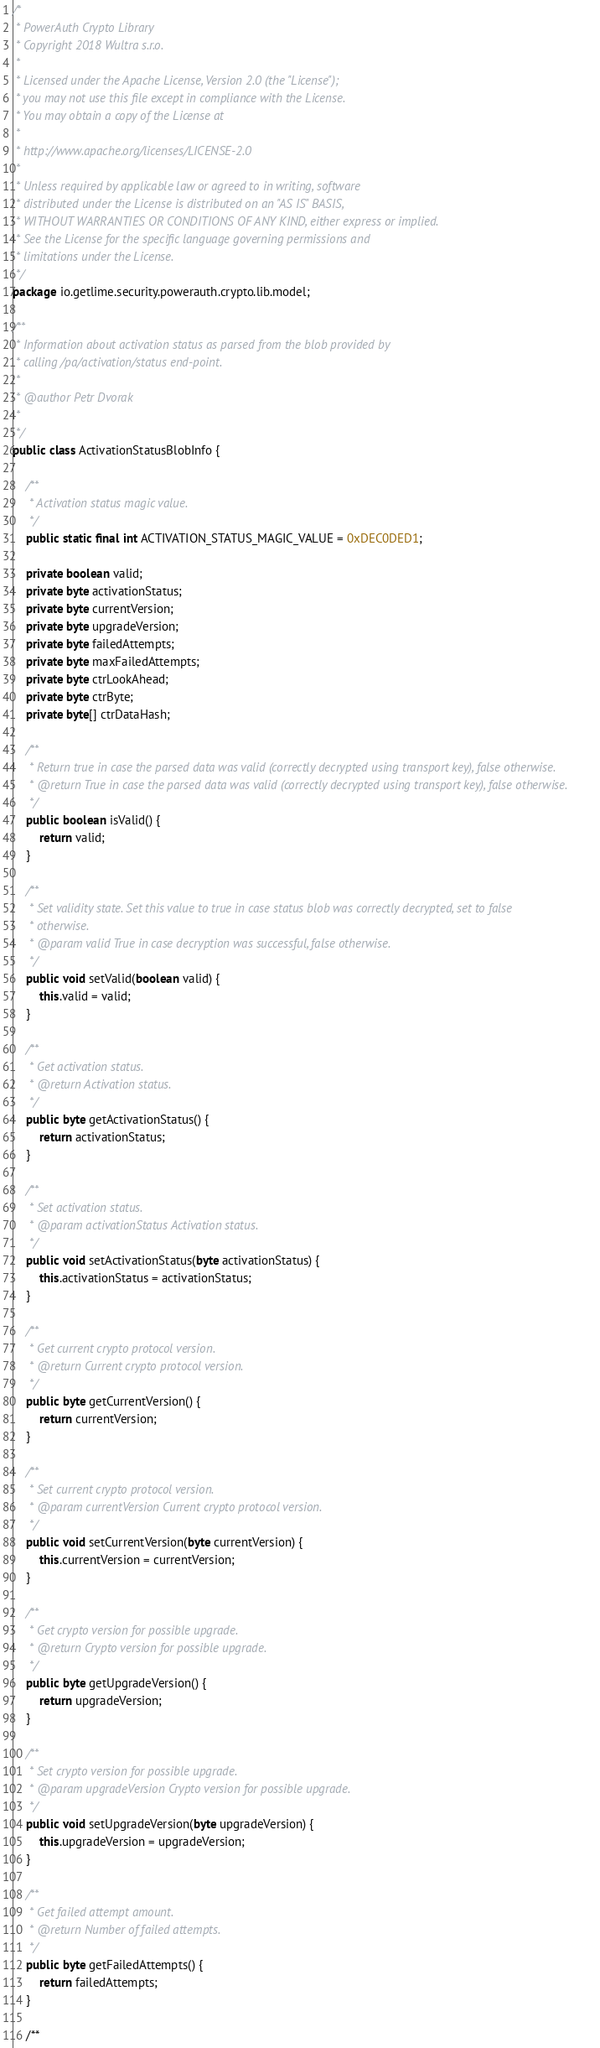<code> <loc_0><loc_0><loc_500><loc_500><_Java_>/*
 * PowerAuth Crypto Library
 * Copyright 2018 Wultra s.r.o.
 *
 * Licensed under the Apache License, Version 2.0 (the "License");
 * you may not use this file except in compliance with the License.
 * You may obtain a copy of the License at
 *
 * http://www.apache.org/licenses/LICENSE-2.0
 *
 * Unless required by applicable law or agreed to in writing, software
 * distributed under the License is distributed on an "AS IS" BASIS,
 * WITHOUT WARRANTIES OR CONDITIONS OF ANY KIND, either express or implied.
 * See the License for the specific language governing permissions and
 * limitations under the License.
 */
package io.getlime.security.powerauth.crypto.lib.model;

/**
 * Information about activation status as parsed from the blob provided by
 * calling /pa/activation/status end-point.
 *
 * @author Petr Dvorak
 *
 */
public class ActivationStatusBlobInfo {

    /**
     * Activation status magic value.
     */
    public static final int ACTIVATION_STATUS_MAGIC_VALUE = 0xDEC0DED1;

    private boolean valid;
    private byte activationStatus;
    private byte currentVersion;
    private byte upgradeVersion;
    private byte failedAttempts;
    private byte maxFailedAttempts;
    private byte ctrLookAhead;
    private byte ctrByte;
    private byte[] ctrDataHash;

    /**
     * Return true in case the parsed data was valid (correctly decrypted using transport key), false otherwise.
     * @return True in case the parsed data was valid (correctly decrypted using transport key), false otherwise.
     */
    public boolean isValid() {
        return valid;
    }

    /**
     * Set validity state. Set this value to true in case status blob was correctly decrypted, set to false
     * otherwise.
     * @param valid True in case decryption was successful, false otherwise.
     */
    public void setValid(boolean valid) {
        this.valid = valid;
    }

    /**
     * Get activation status.
     * @return Activation status.
     */
    public byte getActivationStatus() {
        return activationStatus;
    }

    /**
     * Set activation status.
     * @param activationStatus Activation status.
     */
    public void setActivationStatus(byte activationStatus) {
        this.activationStatus = activationStatus;
    }

    /**
     * Get current crypto protocol version.
     * @return Current crypto protocol version.
     */
    public byte getCurrentVersion() {
        return currentVersion;
    }

    /**
     * Set current crypto protocol version.
     * @param currentVersion Current crypto protocol version.
     */
    public void setCurrentVersion(byte currentVersion) {
        this.currentVersion = currentVersion;
    }

    /**
     * Get crypto version for possible upgrade.
     * @return Crypto version for possible upgrade.
     */
    public byte getUpgradeVersion() {
        return upgradeVersion;
    }

    /**
     * Set crypto version for possible upgrade.
     * @param upgradeVersion Crypto version for possible upgrade.
     */
    public void setUpgradeVersion(byte upgradeVersion) {
        this.upgradeVersion = upgradeVersion;
    }

    /**
     * Get failed attempt amount.
     * @return Number of failed attempts.
     */
    public byte getFailedAttempts() {
        return failedAttempts;
    }

    /**</code> 